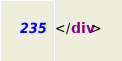Convert code to text. <code><loc_0><loc_0><loc_500><loc_500><_HTML_>

</div>
</code> 